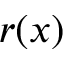Convert formula to latex. <formula><loc_0><loc_0><loc_500><loc_500>r ( x )</formula> 